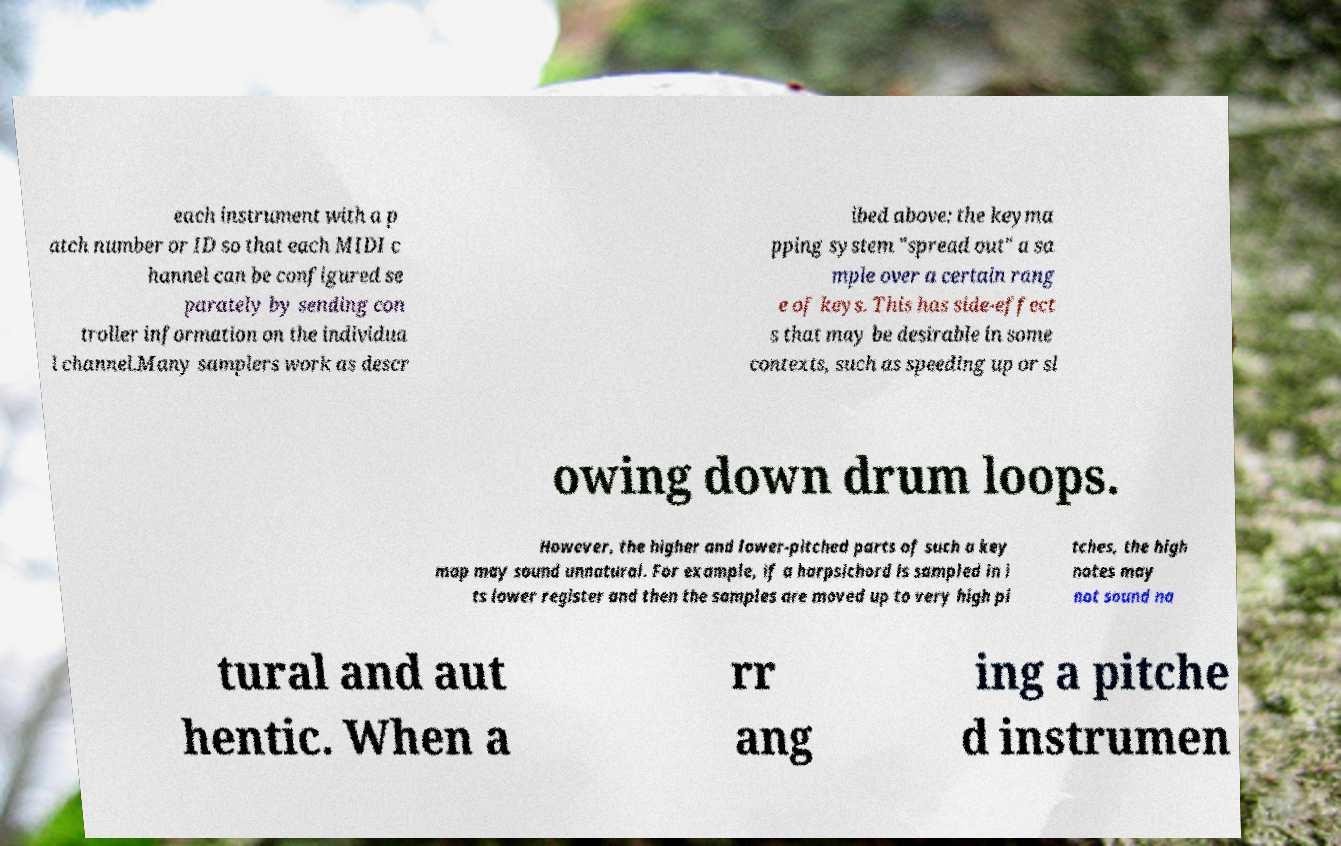Could you assist in decoding the text presented in this image and type it out clearly? each instrument with a p atch number or ID so that each MIDI c hannel can be configured se parately by sending con troller information on the individua l channel.Many samplers work as descr ibed above: the keyma pping system "spread out" a sa mple over a certain rang e of keys. This has side-effect s that may be desirable in some contexts, such as speeding up or sl owing down drum loops. However, the higher and lower-pitched parts of such a key map may sound unnatural. For example, if a harpsichord is sampled in i ts lower register and then the samples are moved up to very high pi tches, the high notes may not sound na tural and aut hentic. When a rr ang ing a pitche d instrumen 